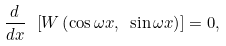Convert formula to latex. <formula><loc_0><loc_0><loc_500><loc_500>\frac { d } { d x } \ \left [ W \left ( \cos \omega x , \ \sin \omega x \right ) \right ] = 0 ,</formula> 